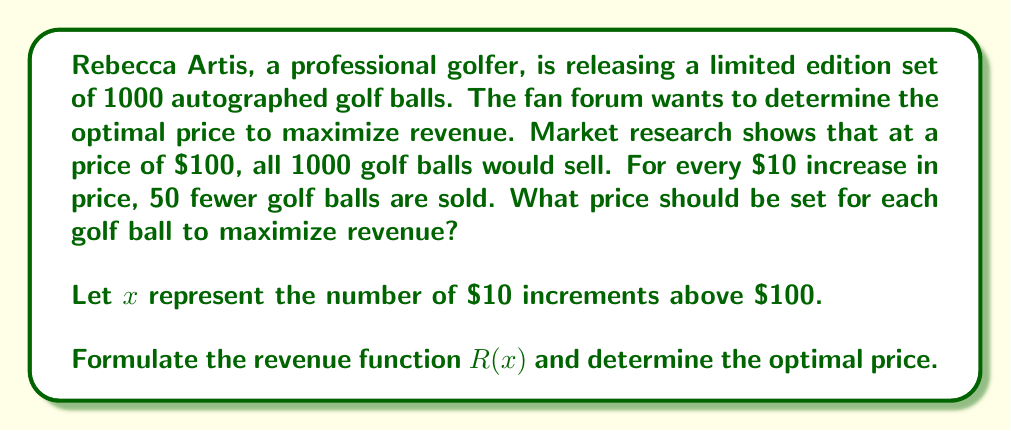Can you answer this question? Let's approach this step-by-step:

1) First, we need to express the quantity sold and price in terms of $x$:
   - Quantity sold: $Q(x) = 1000 - 50x$
   - Price: $P(x) = 100 + 10x$

2) The revenue function is the product of price and quantity:
   $R(x) = P(x) \cdot Q(x)$
   $R(x) = (100 + 10x)(1000 - 50x)$

3) Expand this expression:
   $R(x) = 100000 - 5000x + 10000x - 500x^2$
   $R(x) = 100000 + 5000x - 500x^2$

4) To find the maximum revenue, we need to find where the derivative of $R(x)$ equals zero:
   $\frac{dR}{dx} = 5000 - 1000x$

5) Set this equal to zero and solve for $x$:
   $5000 - 1000x = 0$
   $1000x = 5000$
   $x = 5$

6) To confirm this is a maximum, we can check the second derivative:
   $\frac{d^2R}{dx^2} = -1000$, which is negative, confirming a maximum.

7) Now that we know $x = 5$ maximizes revenue, we can calculate the optimal price:
   $P(5) = 100 + 10(5) = 150$

Therefore, the optimal price for each golf ball is $150.
Answer: The optimal price for each limited edition autographed golf ball is $150. 